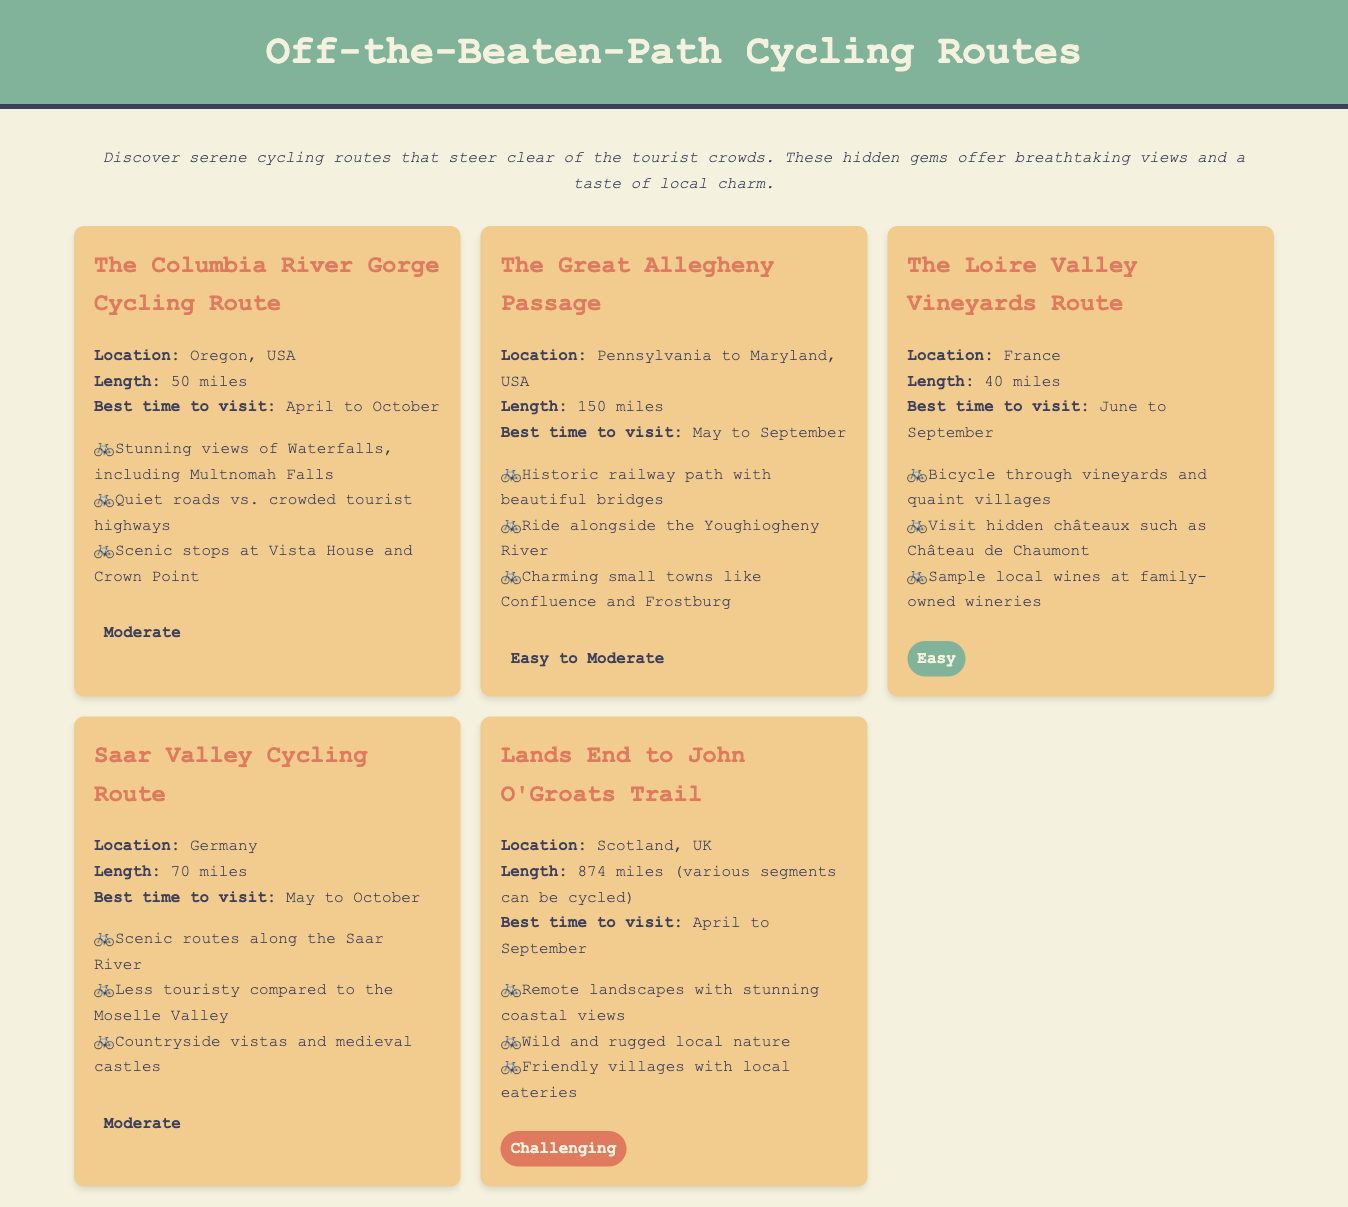What is the location of The Columbia River Gorge Cycling Route? The location is specified as Oregon, USA in the route information.
Answer: Oregon, USA How long is The Great Allegheny Passage? The length of the route is indicated to be 150 miles in the route information.
Answer: 150 miles What is the best time to visit the Loire Valley Vineyards Route? The document states that the best time to visit is from June to September.
Answer: June to September Which route has a challenging difficulty level? The document mentions that the Lands End to John O'Groats Trail has a challenging level of difficulty.
Answer: Lands End to John O'Groats Trail What scenic features are highlighted in the Saar Valley Cycling Route? The highlights list includes scenic routes along the Saar River and vistas of countryside and medieval castles.
Answer: Scenic routes along the Saar River What is the average difficulty level for The Columbia River Gorge Cycling Route? The document categorizes it as a moderate difficulty route.
Answer: Moderate Which route features hidden châteaux? The Loire Valley Vineyards Route is specified to feature hidden châteaux in the highlights.
Answer: The Loire Valley Vineyards Route What type of cycling route is The Great Allegheny Passage known for? The document describes it as a historic railway path in the route information.
Answer: Historic railway path What amenities can cyclists expect in friendly villages along the Lands End to John O'Groats Trail? The highlights mention local eateries available in friendly villages.
Answer: Local eateries 